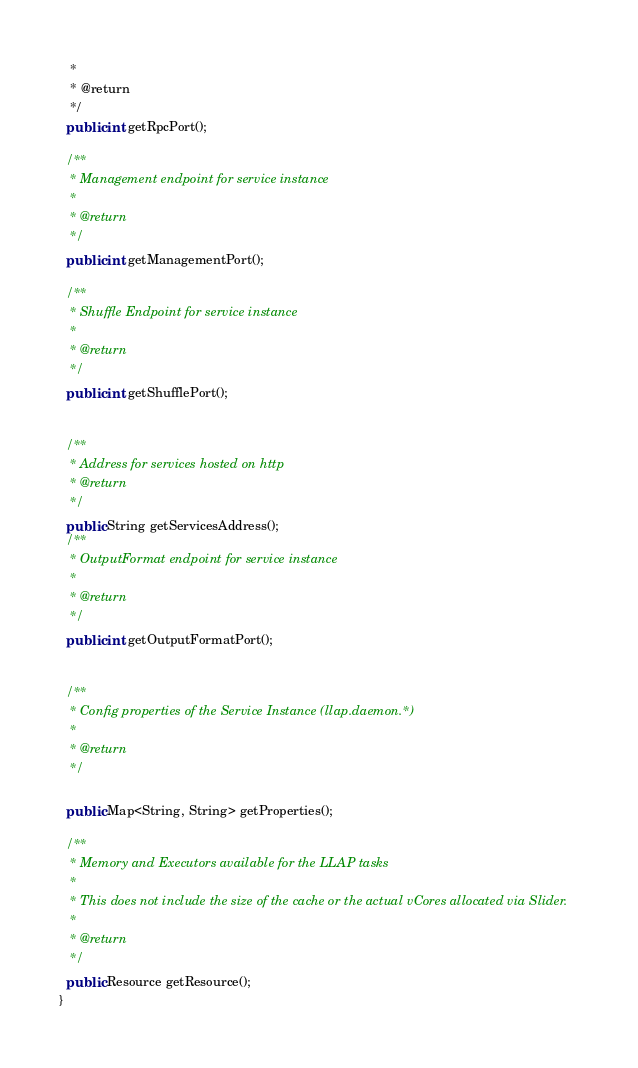Convert code to text. <code><loc_0><loc_0><loc_500><loc_500><_Java_>   * 
   * @return
   */
  public int getRpcPort();

  /**
   * Management endpoint for service instance
   *
   * @return
   */
  public int getManagementPort();

  /**
   * Shuffle Endpoint for service instance
   * 
   * @return
   */
  public int getShufflePort();


  /**
   * Address for services hosted on http
   * @return
   */
  public String getServicesAddress();
  /**
   * OutputFormat endpoint for service instance
   *
   * @return
   */
  public int getOutputFormatPort();


  /**
   * Config properties of the Service Instance (llap.daemon.*)
   * 
   * @return
   */

  public Map<String, String> getProperties();

  /**
   * Memory and Executors available for the LLAP tasks
   * 
   * This does not include the size of the cache or the actual vCores allocated via Slider.
   * 
   * @return
   */
  public Resource getResource();
}
</code> 